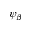Convert formula to latex. <formula><loc_0><loc_0><loc_500><loc_500>\psi _ { \beta }</formula> 